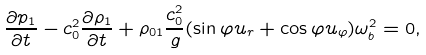<formula> <loc_0><loc_0><loc_500><loc_500>\ \frac { \partial p _ { 1 } } { \partial t } - c _ { 0 } ^ { 2 } \frac { \partial \rho _ { 1 } } { \partial t } + \rho _ { 0 1 } \frac { c _ { 0 } ^ { 2 } } { g } ( \sin \varphi u _ { r } + \cos \varphi u _ { \varphi } ) \omega _ { b } ^ { 2 } = 0 , \</formula> 